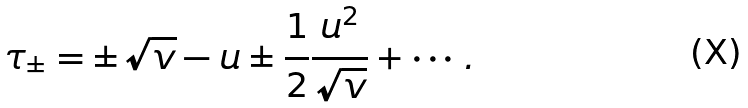Convert formula to latex. <formula><loc_0><loc_0><loc_500><loc_500>\tau _ { \pm } = \pm \sqrt { v } - u \pm \frac { 1 } { 2 } \frac { u ^ { 2 } } { \sqrt { v } } + \cdots .</formula> 